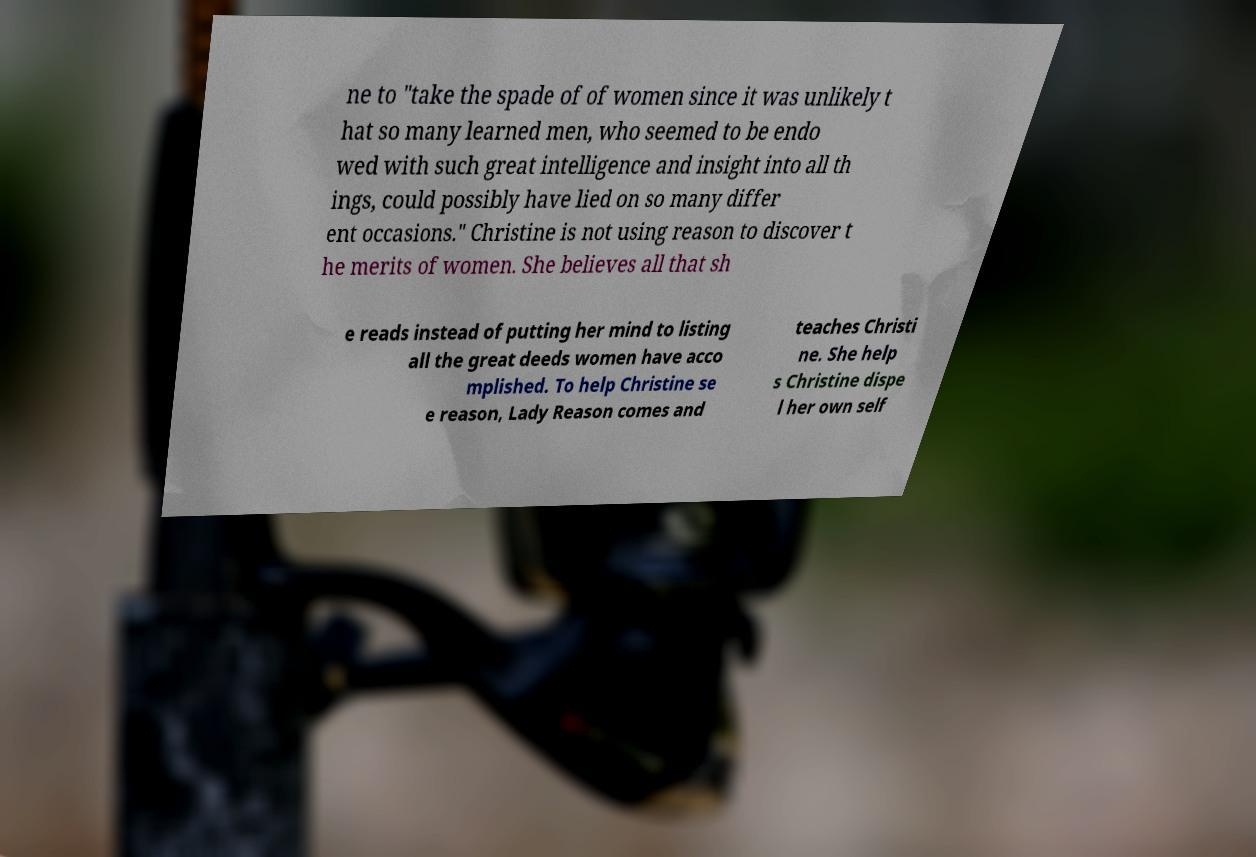Can you accurately transcribe the text from the provided image for me? ne to "take the spade of of women since it was unlikely t hat so many learned men, who seemed to be endo wed with such great intelligence and insight into all th ings, could possibly have lied on so many differ ent occasions." Christine is not using reason to discover t he merits of women. She believes all that sh e reads instead of putting her mind to listing all the great deeds women have acco mplished. To help Christine se e reason, Lady Reason comes and teaches Christi ne. She help s Christine dispe l her own self 